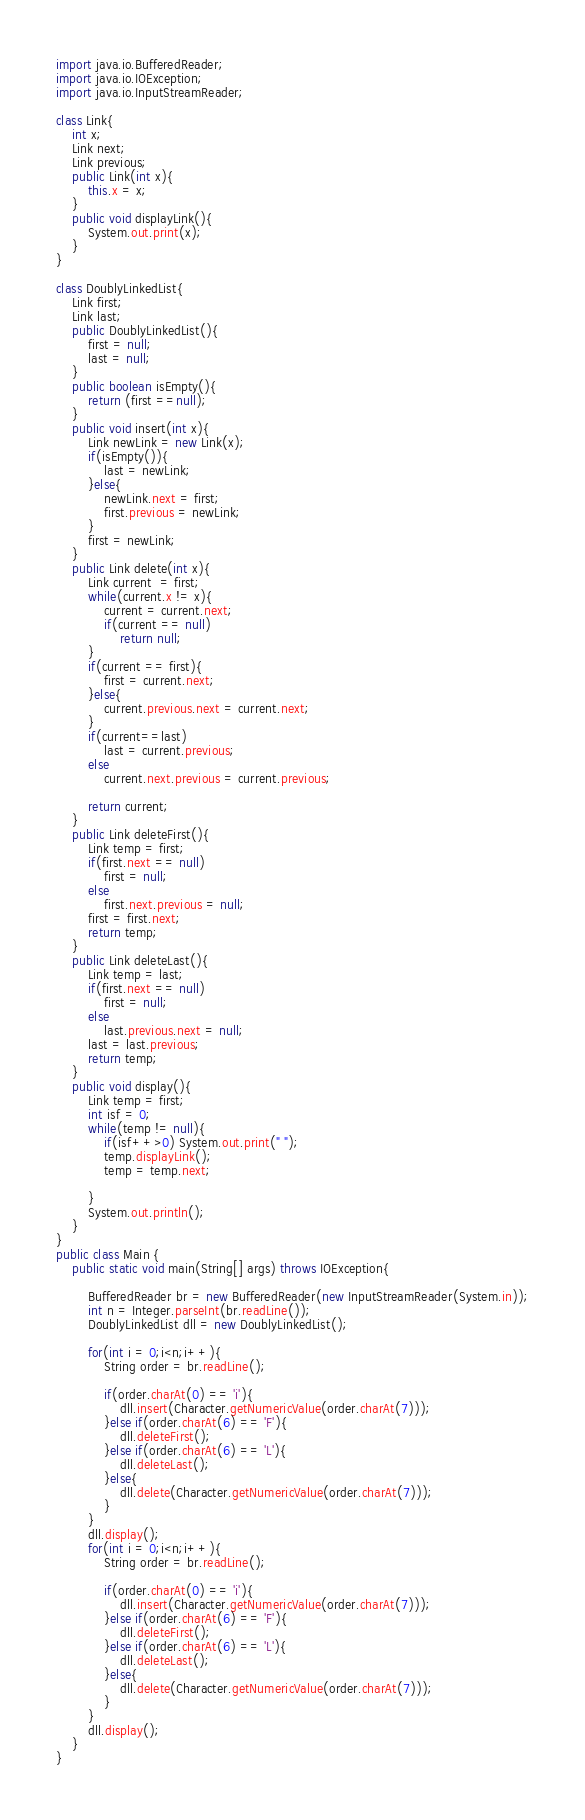Convert code to text. <code><loc_0><loc_0><loc_500><loc_500><_Java_>import java.io.BufferedReader;
import java.io.IOException;
import java.io.InputStreamReader;

class Link{
	int x;
	Link next;
	Link previous;
	public Link(int x){
		this.x = x;
	}
	public void displayLink(){
		System.out.print(x);
	}
}

class DoublyLinkedList{
	Link first;
	Link last;
	public DoublyLinkedList(){
		first = null;
		last = null;
	}
	public boolean isEmpty(){
		return (first ==null);
	}
	public void insert(int x){
		Link newLink = new Link(x);
		if(isEmpty()){
			last = newLink;
		}else{
			newLink.next = first;
			first.previous = newLink;
		}
		first = newLink;
	}
	public Link delete(int x){
		Link current  = first;
		while(current.x != x){
			current = current.next;
			if(current == null)
				return null;
		}
		if(current == first){
			first = current.next;
		}else{
			current.previous.next = current.next;
		}
		if(current==last)
			last = current.previous;
		else
			current.next.previous = current.previous;
		
		return current;
	}
	public Link deleteFirst(){
		Link temp = first;
		if(first.next == null)
			first = null;
		else
			first.next.previous = null;
		first = first.next;
		return temp;
	}
	public Link deleteLast(){
		Link temp = last;
		if(first.next == null)
			first = null;
		else
			last.previous.next = null;
		last = last.previous;
		return temp;
	}
	public void display(){
		Link temp = first;
		int isf = 0;
		while(temp != null){
			if(isf++>0) System.out.print(" ");
			temp.displayLink();
			temp = temp.next;
		
		}
		System.out.println();
	}
}
public class Main {
	public static void main(String[] args) throws IOException{
		
		BufferedReader br = new BufferedReader(new InputStreamReader(System.in));
		int n = Integer.parseInt(br.readLine());
		DoublyLinkedList dll = new DoublyLinkedList();
		
		for(int i = 0;i<n;i++){
			String order = br.readLine();
		
			if(order.charAt(0) == 'i'){
				dll.insert(Character.getNumericValue(order.charAt(7)));
			}else if(order.charAt(6) == 'F'){
				dll.deleteFirst();
			}else if(order.charAt(6) == 'L'){
				dll.deleteLast();
			}else{
				dll.delete(Character.getNumericValue(order.charAt(7)));
			}
		}
		dll.display();
		for(int i = 0;i<n;i++){
			String order = br.readLine();
		
			if(order.charAt(0) == 'i'){
				dll.insert(Character.getNumericValue(order.charAt(7)));
			}else if(order.charAt(6) == 'F'){
				dll.deleteFirst();
			}else if(order.charAt(6) == 'L'){
				dll.deleteLast();
			}else{
				dll.delete(Character.getNumericValue(order.charAt(7)));
			}
		}
		dll.display();
	}
}</code> 